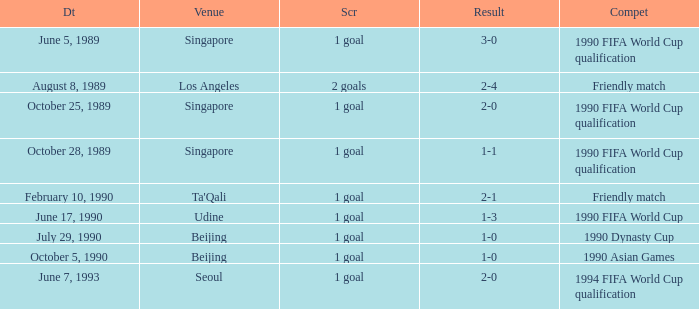What is the venue of the 1990 Asian games? Beijing. 